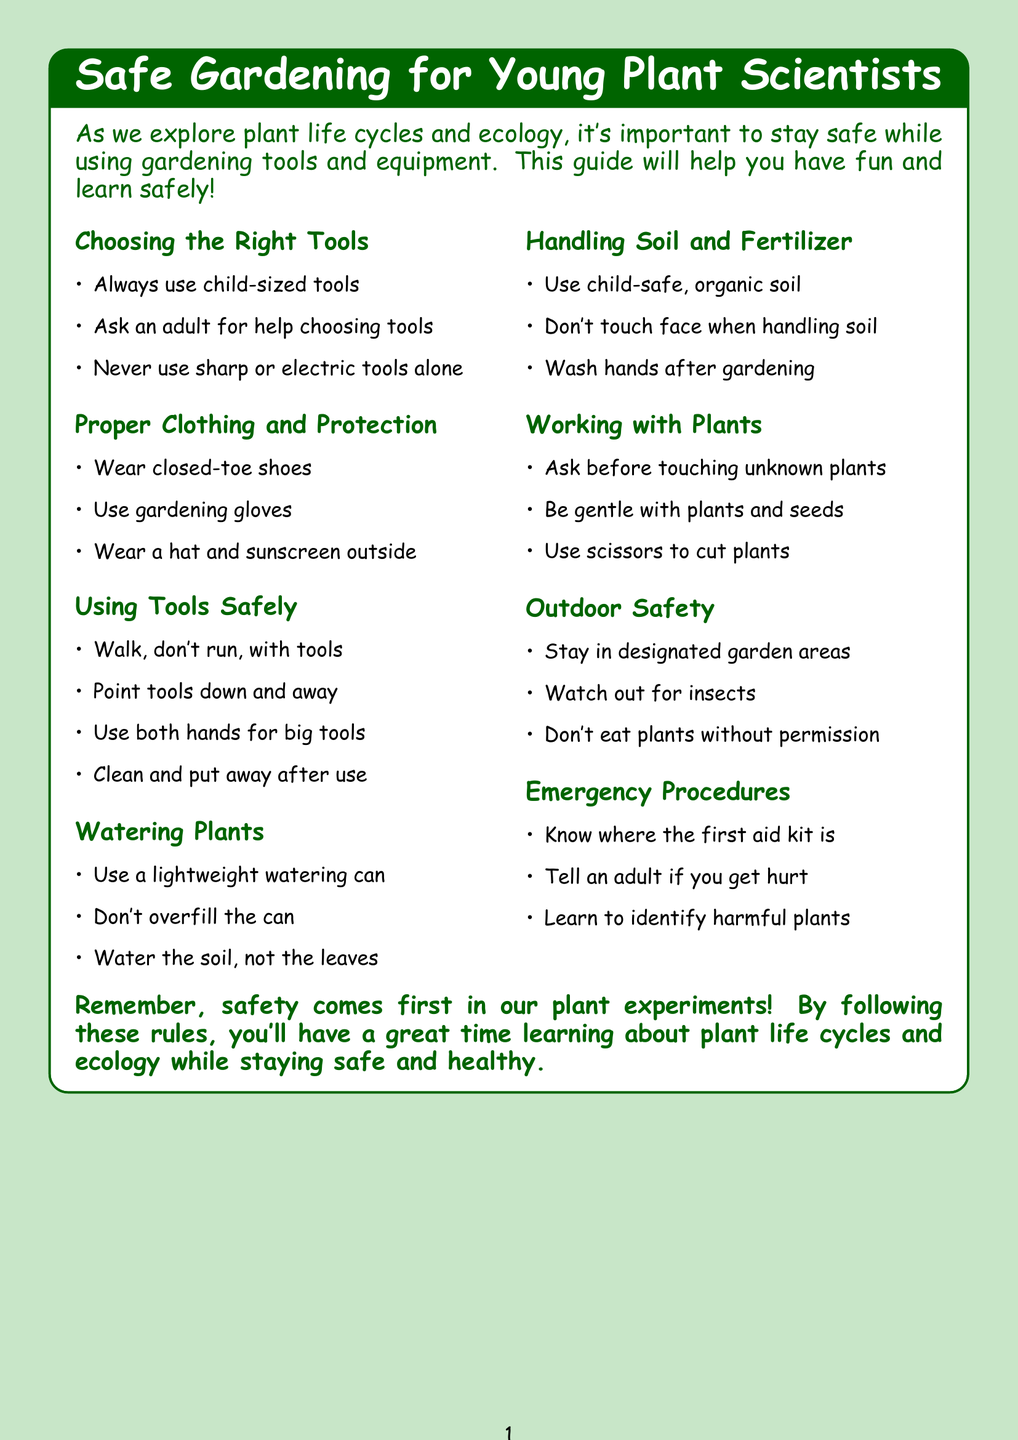What is the title of the policy document? The title is stated at the start of the document, highlighting the main focus of the guide.
Answer: Safe Gardening for Young Plant Scientists What type of shoes should you wear while gardening? The document specifies the type of footwear that is safe for gardening activities.
Answer: Closed-toe shoes Who should help you choose the right gardening tools? The document indicates who you should consult for advice on selecting appropriate tools.
Answer: Teacher or a grown-up What should you do with your tools after using them? The document provides guidance on tool management after gardening tasks are completed.
Answer: Clean and put away tools What should you use to water the plants? The document suggests a specific type of watering can that is suitable for children.
Answer: Lightweight watering can Why should you wash your hands after gardening? The document emphasizes the importance of hygiene after handling gardening materials.
Answer: To keep safe and clean What should you do if you get hurt? The document outlines the appropriate response in case of an injury while gardening.
Answer: Tell a teacher or adult What type of soil should you use? The document specifies a safe and recommended type of soil for gardening activities.
Answer: Child-safe, organic potting soil What should you do when working with unknown plants? The document provides a safety guideline for handling unfamiliar plants.
Answer: Ask an adult before touching 